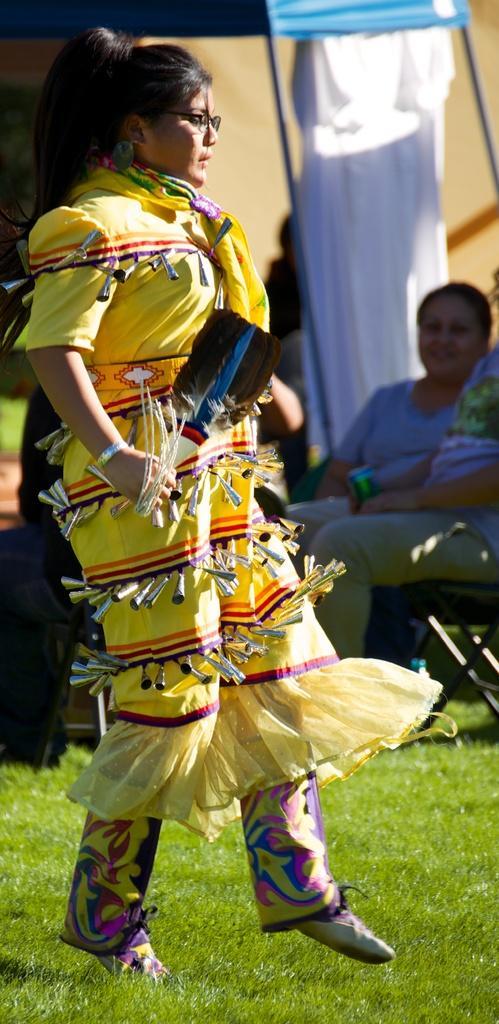Please provide a concise description of this image. In this image we can see a woman wearing a dress and holding stick in her hand is standing on the ground. In the background, we can see a person is sitting on a chair and a tent. 